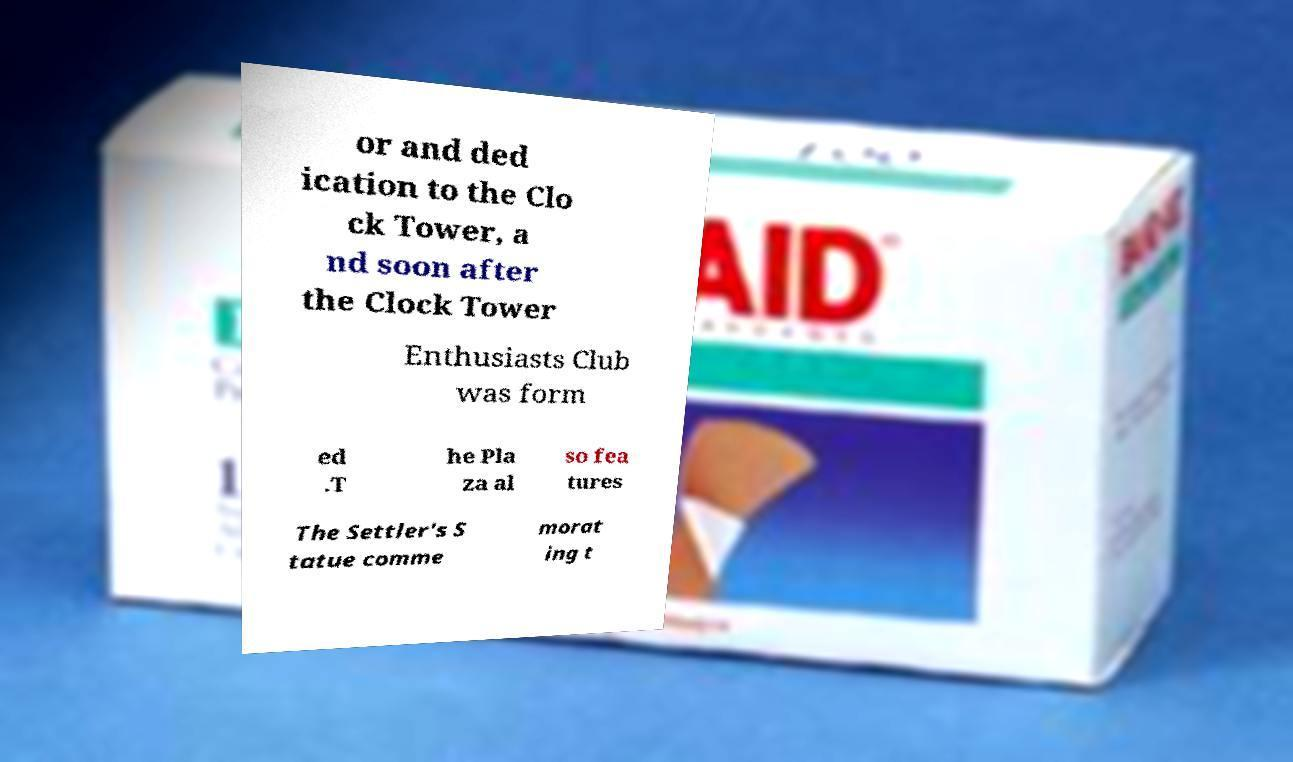I need the written content from this picture converted into text. Can you do that? or and ded ication to the Clo ck Tower, a nd soon after the Clock Tower Enthusiasts Club was form ed .T he Pla za al so fea tures The Settler's S tatue comme morat ing t 